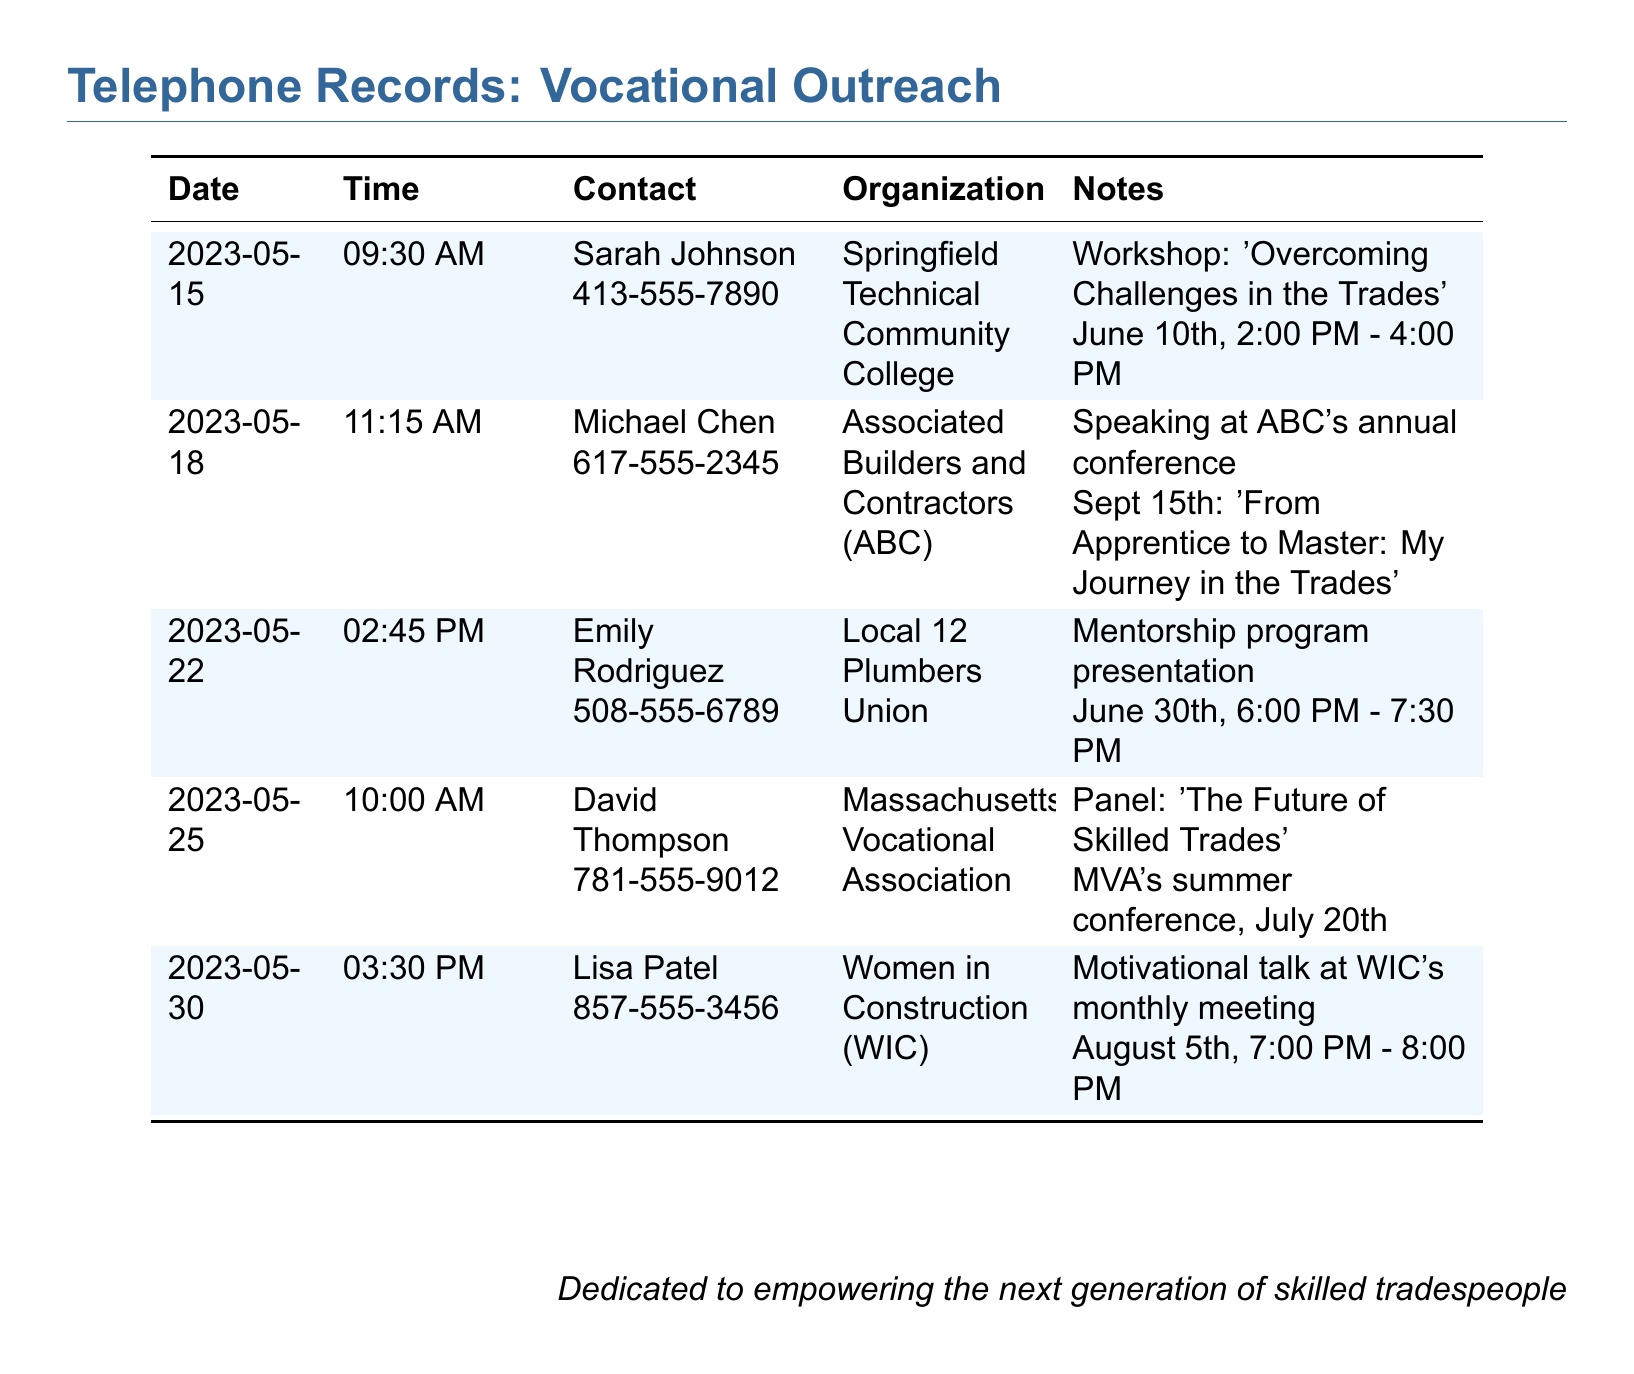What is the date of the workshop on overcoming challenges? The date for the workshop is found in the record of Sarah Johnson, indicating when the workshop will take place.
Answer: June 10th Who is the contact for the Associated Builders and Contractors? The contact person's name for ABC is provided in the document along with their phone number.
Answer: Michael Chen What is the time of the mentorship program presentation? The time is specified in the entry related to Emily Rodriguez, detailing when the presentation will commence.
Answer: 6:00 PM - 7:30 PM On what date is the panel titled 'The Future of Skilled Trades' scheduled? The date for the panel can be located in the record for David Thompson, indicating when the event will occur.
Answer: July 20th How many speaking engagements are scheduled in total according to the document? The total number of engagements can be counted from the entries listed in the telephone records.
Answer: 5 What is the name of the organization associated with Lisa Patel? The organization name can be found in the entry related to Lisa Patel in the document.
Answer: Women in Construction (WIC) What theme will be discussed at Michael Chen's speaking engagement? The theme is indicated in the notes of the contact entry for Michael Chen regarding his speech at the conference.
Answer: From Apprentice to Master: My Journey in the Trades What type of event is scheduled for June 30th? The event type can be identified in the notes for Emily Rodriguez regarding the presentation related to the mentorship program.
Answer: Mentorship program presentation 